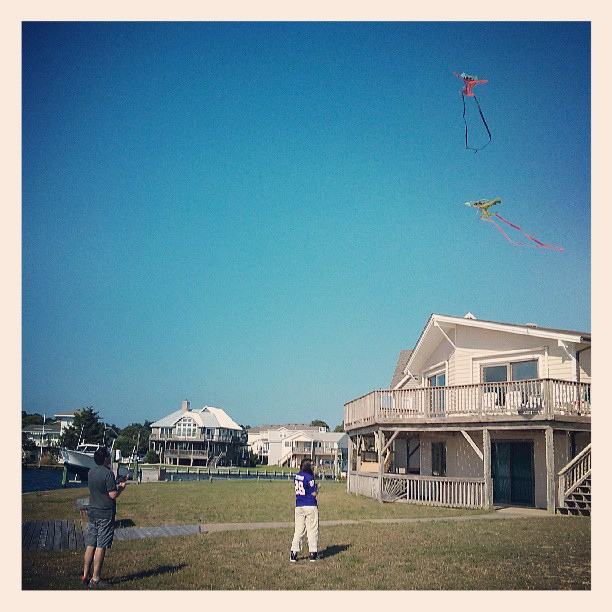<image>What print is it on the blue shirt? I am not sure what print is on the blue shirt. It could be numbers or even '28'. What print is it on the blue shirt? I am not sure what print is on the blue shirt. It can be seen as numbers, 28, number, solid, or white. 